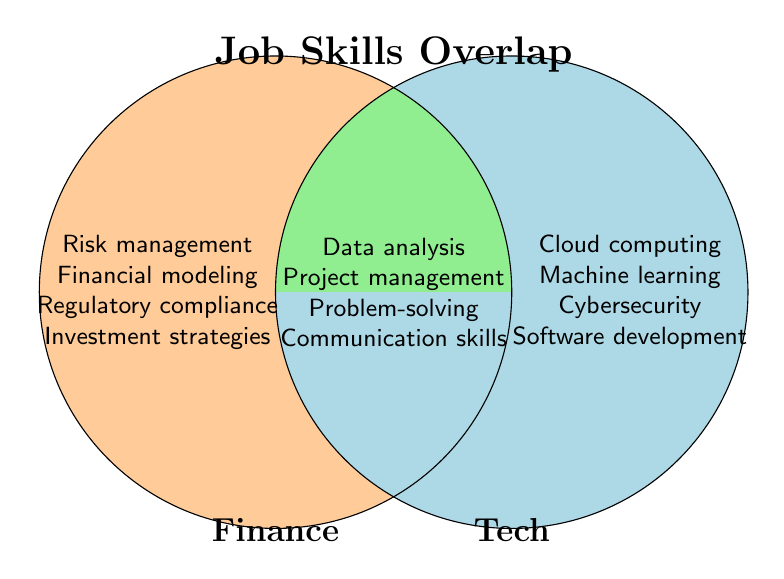What is the title of the Venn diagram? The title is usually found at a prominent location near the top of the diagram. Here, it is located at the top-center of the Venn diagram and is labeled "Job Skills Overlap".
Answer: Job Skills Overlap Which category has the skill 'Risk management'? The skill 'Risk management' is located on the left circle, which represents the Finance category.
Answer: Finance Which category has the skill 'Machine learning'? The skill 'Machine learning' is located on the right circle, which represents the Tech category.
Answer: Tech How many overlapping skills are there between Finance and Tech? The overlapping skills are located in the intersecting area of the two circles. There are four skills mentioned: Data analysis, Project management, Problem-solving, and Communication skills.
Answer: 4 Name two non-overlapping skills in the Tech category. The non-overlapping skills in the Tech category are located in the right circle, excluding the intersecting area. Two such skills are Cloud computing and Machine learning.
Answer: Cloud computing, Machine learning Which category has the skill 'Strategic thinking'? The skill 'Strategic thinking' is not listed in any specific circle for Finance or Tech, indicating it is part of the overlapping skills set.
Answer: Overlap List one skill that is only found in the Finance category. Skills found only in the Finance category are listed in the left circle. One such skill is 'Investment strategies'.
Answer: Investment strategies Compare the count of skills exclusively in Finance and Tech categories. Which category has more unique skills listed? By counting the skills in each non-overlapping area: Finance has 8 skills, and Tech has 8 skills. Both categories have the same amount of unique skills listed.
Answer: Same amount Are there more unique skills in Finance compared to shared skills? Comparing the unique skills in Finance (8) against the shared skills (4): there are more unique skills in Finance.
Answer: More unique skills Which color is used to represent the overlapping area in the Venn diagram? The overlapping area is visually distinct and has a different color from the individual circles. It is colored in light green.
Answer: Light green 